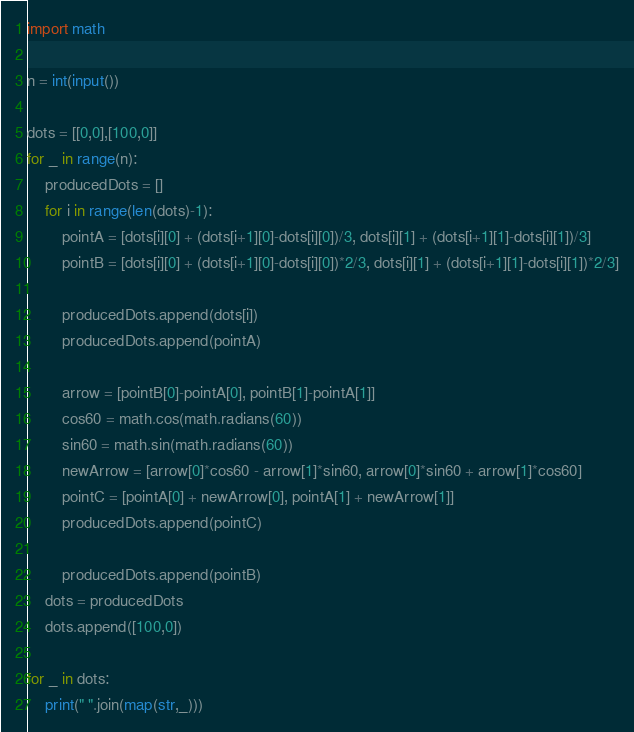Convert code to text. <code><loc_0><loc_0><loc_500><loc_500><_Python_>import math

n = int(input())

dots = [[0,0],[100,0]]
for _ in range(n):
    producedDots = []
    for i in range(len(dots)-1):
        pointA = [dots[i][0] + (dots[i+1][0]-dots[i][0])/3, dots[i][1] + (dots[i+1][1]-dots[i][1])/3]
        pointB = [dots[i][0] + (dots[i+1][0]-dots[i][0])*2/3, dots[i][1] + (dots[i+1][1]-dots[i][1])*2/3]

        producedDots.append(dots[i])
        producedDots.append(pointA)

        arrow = [pointB[0]-pointA[0], pointB[1]-pointA[1]]
        cos60 = math.cos(math.radians(60))
        sin60 = math.sin(math.radians(60))
        newArrow = [arrow[0]*cos60 - arrow[1]*sin60, arrow[0]*sin60 + arrow[1]*cos60]
        pointC = [pointA[0] + newArrow[0], pointA[1] + newArrow[1]]
        producedDots.append(pointC)

        producedDots.append(pointB)
    dots = producedDots
    dots.append([100,0])

for _ in dots:
    print(" ".join(map(str,_)))
</code> 